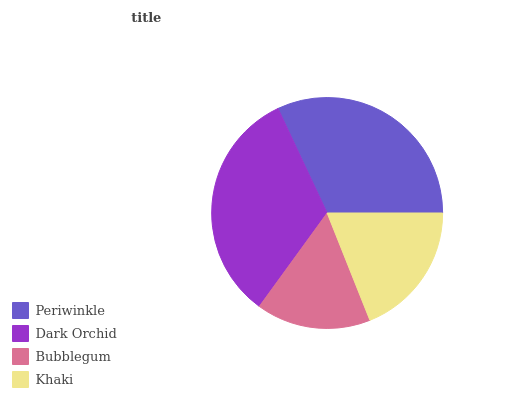Is Bubblegum the minimum?
Answer yes or no. Yes. Is Dark Orchid the maximum?
Answer yes or no. Yes. Is Dark Orchid the minimum?
Answer yes or no. No. Is Bubblegum the maximum?
Answer yes or no. No. Is Dark Orchid greater than Bubblegum?
Answer yes or no. Yes. Is Bubblegum less than Dark Orchid?
Answer yes or no. Yes. Is Bubblegum greater than Dark Orchid?
Answer yes or no. No. Is Dark Orchid less than Bubblegum?
Answer yes or no. No. Is Periwinkle the high median?
Answer yes or no. Yes. Is Khaki the low median?
Answer yes or no. Yes. Is Dark Orchid the high median?
Answer yes or no. No. Is Dark Orchid the low median?
Answer yes or no. No. 